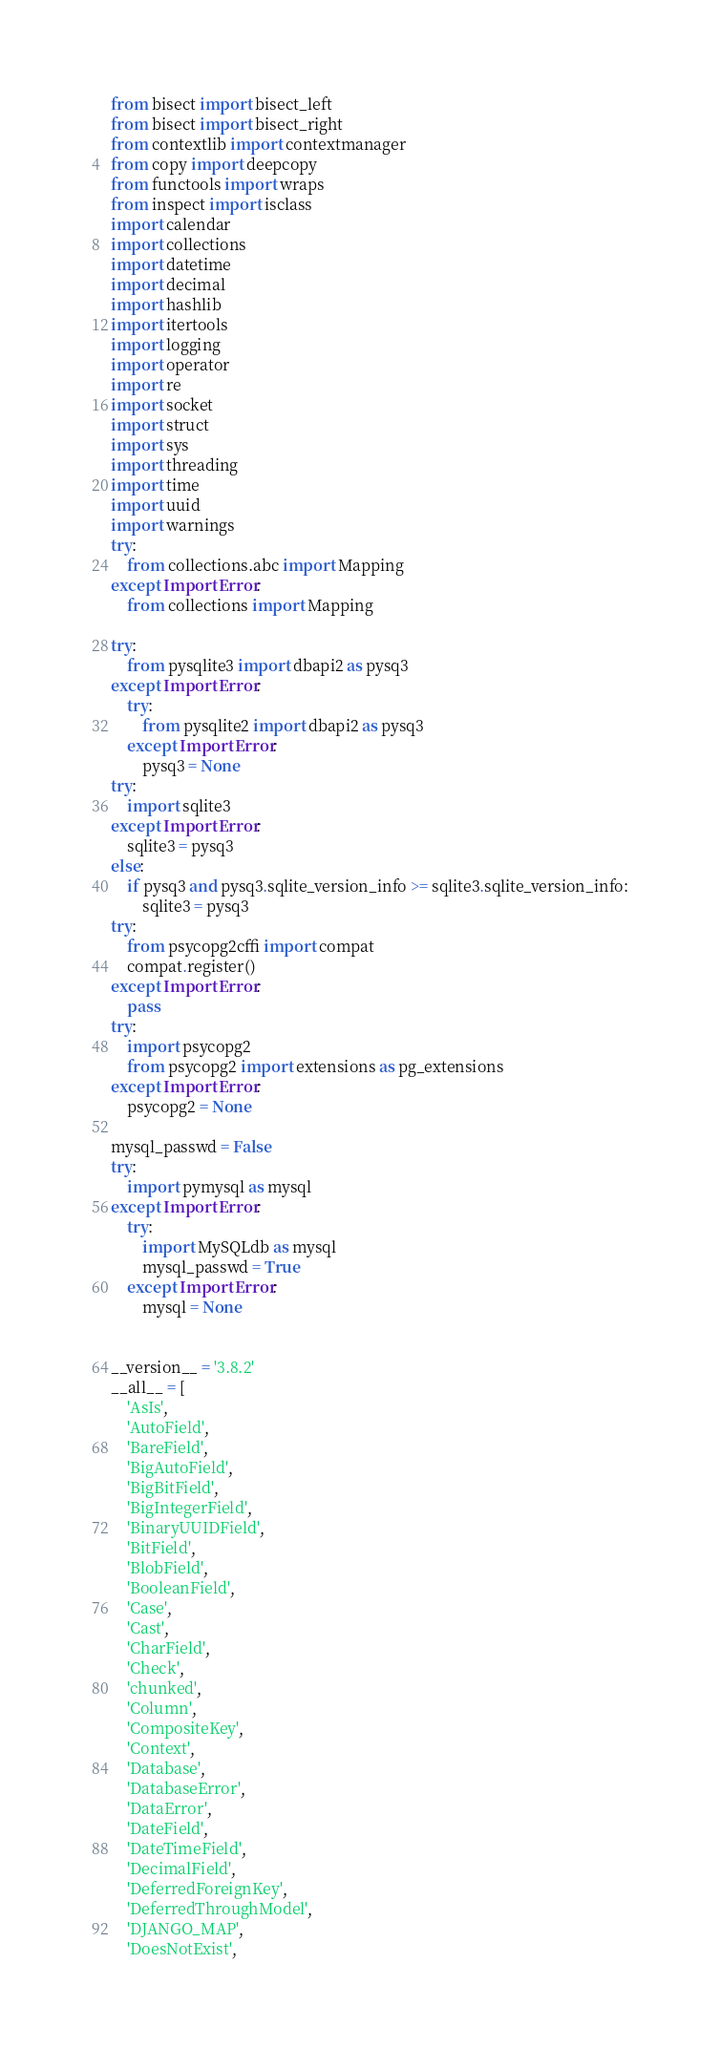<code> <loc_0><loc_0><loc_500><loc_500><_Python_>from bisect import bisect_left
from bisect import bisect_right
from contextlib import contextmanager
from copy import deepcopy
from functools import wraps
from inspect import isclass
import calendar
import collections
import datetime
import decimal
import hashlib
import itertools
import logging
import operator
import re
import socket
import struct
import sys
import threading
import time
import uuid
import warnings
try:
    from collections.abc import Mapping
except ImportError:
    from collections import Mapping

try:
    from pysqlite3 import dbapi2 as pysq3
except ImportError:
    try:
        from pysqlite2 import dbapi2 as pysq3
    except ImportError:
        pysq3 = None
try:
    import sqlite3
except ImportError:
    sqlite3 = pysq3
else:
    if pysq3 and pysq3.sqlite_version_info >= sqlite3.sqlite_version_info:
        sqlite3 = pysq3
try:
    from psycopg2cffi import compat
    compat.register()
except ImportError:
    pass
try:
    import psycopg2
    from psycopg2 import extensions as pg_extensions
except ImportError:
    psycopg2 = None

mysql_passwd = False
try:
    import pymysql as mysql
except ImportError:
    try:
        import MySQLdb as mysql
        mysql_passwd = True
    except ImportError:
        mysql = None


__version__ = '3.8.2'
__all__ = [
    'AsIs',
    'AutoField',
    'BareField',
    'BigAutoField',
    'BigBitField',
    'BigIntegerField',
    'BinaryUUIDField',
    'BitField',
    'BlobField',
    'BooleanField',
    'Case',
    'Cast',
    'CharField',
    'Check',
    'chunked',
    'Column',
    'CompositeKey',
    'Context',
    'Database',
    'DatabaseError',
    'DataError',
    'DateField',
    'DateTimeField',
    'DecimalField',
    'DeferredForeignKey',
    'DeferredThroughModel',
    'DJANGO_MAP',
    'DoesNotExist',</code> 